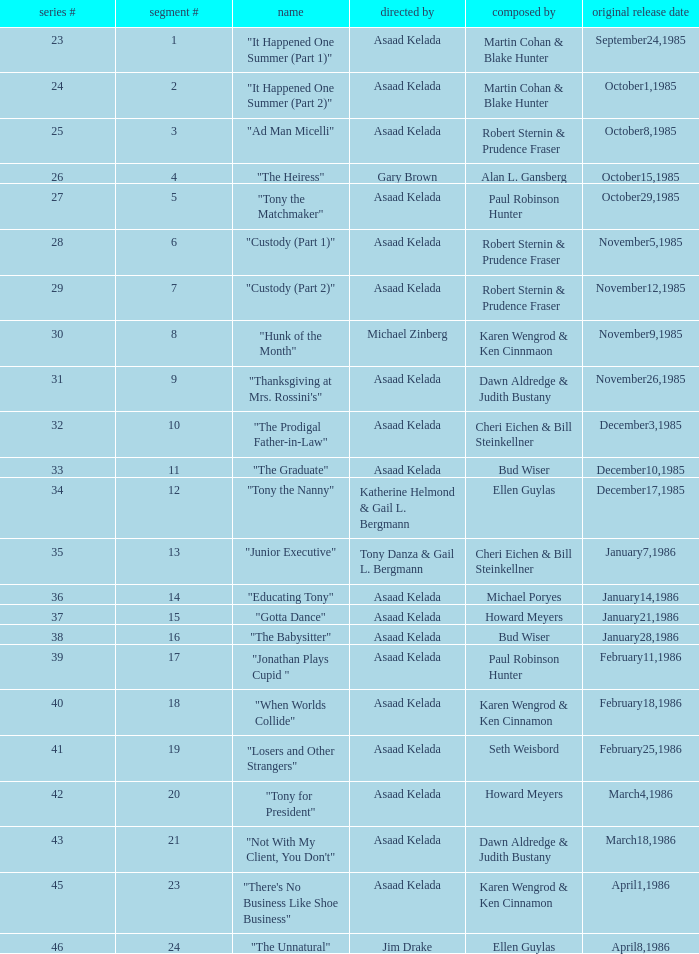What is the date of the episode written by Michael Poryes? January14,1986. Write the full table. {'header': ['series #', 'segment #', 'name', 'directed by', 'composed by', 'original release date'], 'rows': [['23', '1', '"It Happened One Summer (Part 1)"', 'Asaad Kelada', 'Martin Cohan & Blake Hunter', 'September24,1985'], ['24', '2', '"It Happened One Summer (Part 2)"', 'Asaad Kelada', 'Martin Cohan & Blake Hunter', 'October1,1985'], ['25', '3', '"Ad Man Micelli"', 'Asaad Kelada', 'Robert Sternin & Prudence Fraser', 'October8,1985'], ['26', '4', '"The Heiress"', 'Gary Brown', 'Alan L. Gansberg', 'October15,1985'], ['27', '5', '"Tony the Matchmaker"', 'Asaad Kelada', 'Paul Robinson Hunter', 'October29,1985'], ['28', '6', '"Custody (Part 1)"', 'Asaad Kelada', 'Robert Sternin & Prudence Fraser', 'November5,1985'], ['29', '7', '"Custody (Part 2)"', 'Asaad Kelada', 'Robert Sternin & Prudence Fraser', 'November12,1985'], ['30', '8', '"Hunk of the Month"', 'Michael Zinberg', 'Karen Wengrod & Ken Cinnmaon', 'November9,1985'], ['31', '9', '"Thanksgiving at Mrs. Rossini\'s"', 'Asaad Kelada', 'Dawn Aldredge & Judith Bustany', 'November26,1985'], ['32', '10', '"The Prodigal Father-in-Law"', 'Asaad Kelada', 'Cheri Eichen & Bill Steinkellner', 'December3,1985'], ['33', '11', '"The Graduate"', 'Asaad Kelada', 'Bud Wiser', 'December10,1985'], ['34', '12', '"Tony the Nanny"', 'Katherine Helmond & Gail L. Bergmann', 'Ellen Guylas', 'December17,1985'], ['35', '13', '"Junior Executive"', 'Tony Danza & Gail L. Bergmann', 'Cheri Eichen & Bill Steinkellner', 'January7,1986'], ['36', '14', '"Educating Tony"', 'Asaad Kelada', 'Michael Poryes', 'January14,1986'], ['37', '15', '"Gotta Dance"', 'Asaad Kelada', 'Howard Meyers', 'January21,1986'], ['38', '16', '"The Babysitter"', 'Asaad Kelada', 'Bud Wiser', 'January28,1986'], ['39', '17', '"Jonathan Plays Cupid "', 'Asaad Kelada', 'Paul Robinson Hunter', 'February11,1986'], ['40', '18', '"When Worlds Collide"', 'Asaad Kelada', 'Karen Wengrod & Ken Cinnamon', 'February18,1986'], ['41', '19', '"Losers and Other Strangers"', 'Asaad Kelada', 'Seth Weisbord', 'February25,1986'], ['42', '20', '"Tony for President"', 'Asaad Kelada', 'Howard Meyers', 'March4,1986'], ['43', '21', '"Not With My Client, You Don\'t"', 'Asaad Kelada', 'Dawn Aldredge & Judith Bustany', 'March18,1986'], ['45', '23', '"There\'s No Business Like Shoe Business"', 'Asaad Kelada', 'Karen Wengrod & Ken Cinnamon', 'April1,1986'], ['46', '24', '"The Unnatural"', 'Jim Drake', 'Ellen Guylas', 'April8,1986']]} 